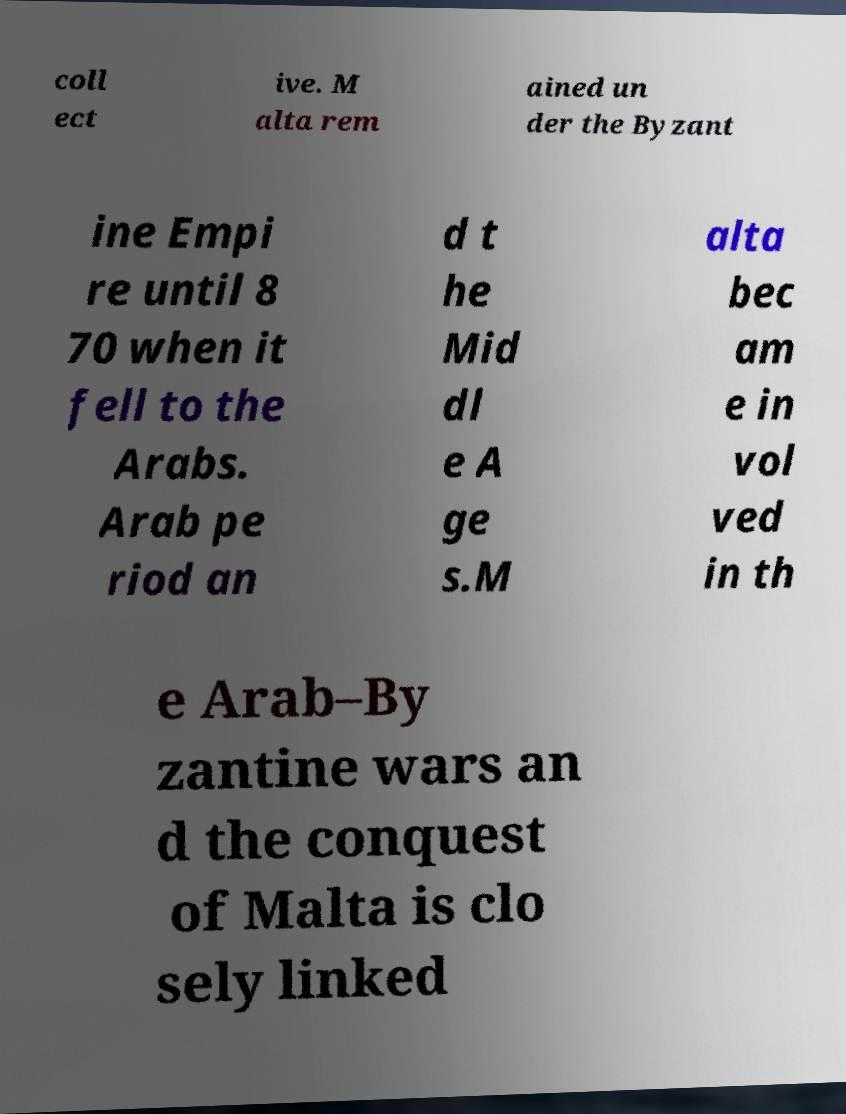Please identify and transcribe the text found in this image. coll ect ive. M alta rem ained un der the Byzant ine Empi re until 8 70 when it fell to the Arabs. Arab pe riod an d t he Mid dl e A ge s.M alta bec am e in vol ved in th e Arab–By zantine wars an d the conquest of Malta is clo sely linked 